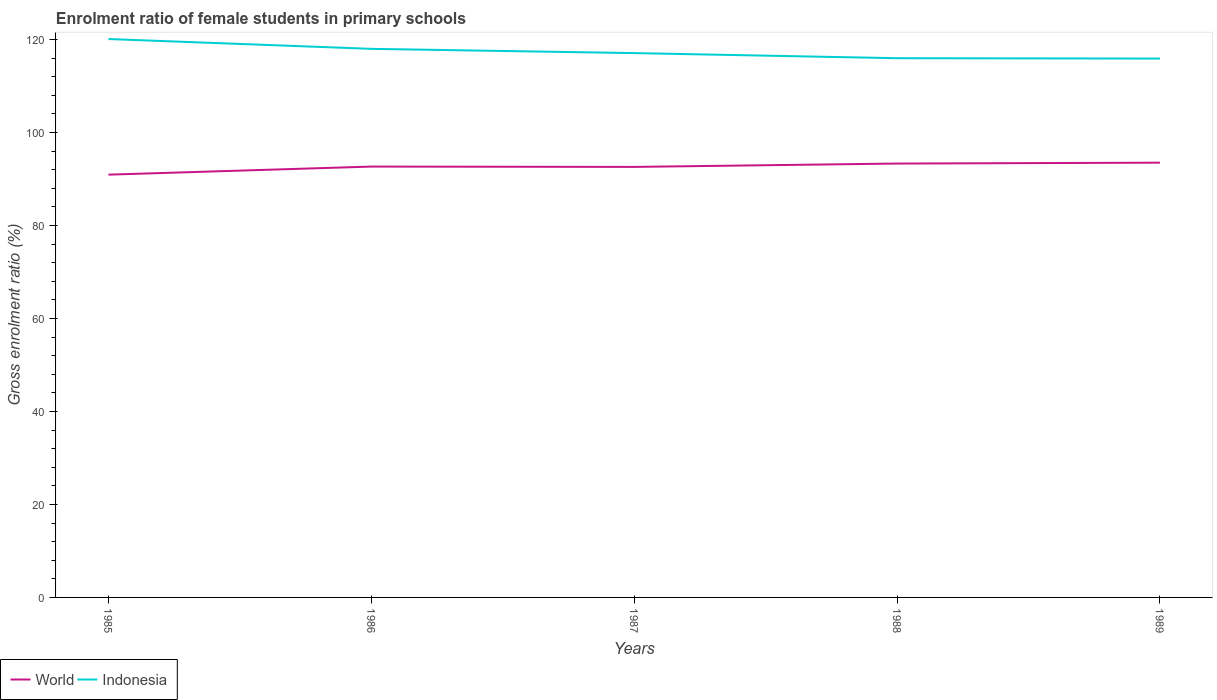Is the number of lines equal to the number of legend labels?
Your answer should be compact. Yes. Across all years, what is the maximum enrolment ratio of female students in primary schools in Indonesia?
Offer a very short reply. 115.91. What is the total enrolment ratio of female students in primary schools in Indonesia in the graph?
Offer a very short reply. 2.01. What is the difference between the highest and the second highest enrolment ratio of female students in primary schools in Indonesia?
Your answer should be very brief. 4.2. What is the difference between the highest and the lowest enrolment ratio of female students in primary schools in World?
Make the answer very short. 3. Is the enrolment ratio of female students in primary schools in World strictly greater than the enrolment ratio of female students in primary schools in Indonesia over the years?
Ensure brevity in your answer.  Yes. How many years are there in the graph?
Your answer should be very brief. 5. Does the graph contain any zero values?
Offer a very short reply. No. Does the graph contain grids?
Your response must be concise. No. Where does the legend appear in the graph?
Provide a short and direct response. Bottom left. How many legend labels are there?
Give a very brief answer. 2. What is the title of the graph?
Your answer should be compact. Enrolment ratio of female students in primary schools. Does "Pacific island small states" appear as one of the legend labels in the graph?
Provide a succinct answer. No. What is the label or title of the X-axis?
Give a very brief answer. Years. What is the label or title of the Y-axis?
Your answer should be very brief. Gross enrolment ratio (%). What is the Gross enrolment ratio (%) in World in 1985?
Provide a succinct answer. 90.94. What is the Gross enrolment ratio (%) of Indonesia in 1985?
Provide a short and direct response. 120.11. What is the Gross enrolment ratio (%) of World in 1986?
Offer a terse response. 92.68. What is the Gross enrolment ratio (%) of Indonesia in 1986?
Keep it short and to the point. 118. What is the Gross enrolment ratio (%) of World in 1987?
Ensure brevity in your answer.  92.61. What is the Gross enrolment ratio (%) of Indonesia in 1987?
Your answer should be very brief. 117.09. What is the Gross enrolment ratio (%) in World in 1988?
Keep it short and to the point. 93.33. What is the Gross enrolment ratio (%) of Indonesia in 1988?
Your answer should be compact. 115.99. What is the Gross enrolment ratio (%) in World in 1989?
Your answer should be compact. 93.52. What is the Gross enrolment ratio (%) of Indonesia in 1989?
Provide a succinct answer. 115.91. Across all years, what is the maximum Gross enrolment ratio (%) of World?
Provide a short and direct response. 93.52. Across all years, what is the maximum Gross enrolment ratio (%) of Indonesia?
Offer a very short reply. 120.11. Across all years, what is the minimum Gross enrolment ratio (%) of World?
Keep it short and to the point. 90.94. Across all years, what is the minimum Gross enrolment ratio (%) of Indonesia?
Offer a very short reply. 115.91. What is the total Gross enrolment ratio (%) in World in the graph?
Your answer should be very brief. 463.07. What is the total Gross enrolment ratio (%) of Indonesia in the graph?
Offer a very short reply. 587.11. What is the difference between the Gross enrolment ratio (%) of World in 1985 and that in 1986?
Make the answer very short. -1.74. What is the difference between the Gross enrolment ratio (%) of Indonesia in 1985 and that in 1986?
Your answer should be very brief. 2.11. What is the difference between the Gross enrolment ratio (%) in World in 1985 and that in 1987?
Offer a very short reply. -1.67. What is the difference between the Gross enrolment ratio (%) of Indonesia in 1985 and that in 1987?
Provide a short and direct response. 3.03. What is the difference between the Gross enrolment ratio (%) of World in 1985 and that in 1988?
Provide a succinct answer. -2.39. What is the difference between the Gross enrolment ratio (%) in Indonesia in 1985 and that in 1988?
Give a very brief answer. 4.12. What is the difference between the Gross enrolment ratio (%) of World in 1985 and that in 1989?
Offer a terse response. -2.58. What is the difference between the Gross enrolment ratio (%) in Indonesia in 1985 and that in 1989?
Provide a short and direct response. 4.2. What is the difference between the Gross enrolment ratio (%) of World in 1986 and that in 1987?
Offer a terse response. 0.07. What is the difference between the Gross enrolment ratio (%) of Indonesia in 1986 and that in 1987?
Offer a very short reply. 0.92. What is the difference between the Gross enrolment ratio (%) in World in 1986 and that in 1988?
Keep it short and to the point. -0.65. What is the difference between the Gross enrolment ratio (%) in Indonesia in 1986 and that in 1988?
Offer a terse response. 2.01. What is the difference between the Gross enrolment ratio (%) in World in 1986 and that in 1989?
Offer a very short reply. -0.84. What is the difference between the Gross enrolment ratio (%) in Indonesia in 1986 and that in 1989?
Give a very brief answer. 2.09. What is the difference between the Gross enrolment ratio (%) in World in 1987 and that in 1988?
Give a very brief answer. -0.72. What is the difference between the Gross enrolment ratio (%) in Indonesia in 1987 and that in 1988?
Provide a succinct answer. 1.1. What is the difference between the Gross enrolment ratio (%) in World in 1987 and that in 1989?
Offer a very short reply. -0.91. What is the difference between the Gross enrolment ratio (%) of Indonesia in 1987 and that in 1989?
Ensure brevity in your answer.  1.18. What is the difference between the Gross enrolment ratio (%) in World in 1988 and that in 1989?
Offer a very short reply. -0.19. What is the difference between the Gross enrolment ratio (%) of Indonesia in 1988 and that in 1989?
Ensure brevity in your answer.  0.08. What is the difference between the Gross enrolment ratio (%) in World in 1985 and the Gross enrolment ratio (%) in Indonesia in 1986?
Provide a succinct answer. -27.06. What is the difference between the Gross enrolment ratio (%) in World in 1985 and the Gross enrolment ratio (%) in Indonesia in 1987?
Give a very brief answer. -26.15. What is the difference between the Gross enrolment ratio (%) in World in 1985 and the Gross enrolment ratio (%) in Indonesia in 1988?
Ensure brevity in your answer.  -25.05. What is the difference between the Gross enrolment ratio (%) in World in 1985 and the Gross enrolment ratio (%) in Indonesia in 1989?
Offer a very short reply. -24.97. What is the difference between the Gross enrolment ratio (%) in World in 1986 and the Gross enrolment ratio (%) in Indonesia in 1987?
Offer a terse response. -24.41. What is the difference between the Gross enrolment ratio (%) of World in 1986 and the Gross enrolment ratio (%) of Indonesia in 1988?
Ensure brevity in your answer.  -23.31. What is the difference between the Gross enrolment ratio (%) of World in 1986 and the Gross enrolment ratio (%) of Indonesia in 1989?
Give a very brief answer. -23.23. What is the difference between the Gross enrolment ratio (%) of World in 1987 and the Gross enrolment ratio (%) of Indonesia in 1988?
Make the answer very short. -23.38. What is the difference between the Gross enrolment ratio (%) of World in 1987 and the Gross enrolment ratio (%) of Indonesia in 1989?
Your answer should be compact. -23.3. What is the difference between the Gross enrolment ratio (%) in World in 1988 and the Gross enrolment ratio (%) in Indonesia in 1989?
Your response must be concise. -22.58. What is the average Gross enrolment ratio (%) in World per year?
Make the answer very short. 92.61. What is the average Gross enrolment ratio (%) in Indonesia per year?
Your answer should be compact. 117.42. In the year 1985, what is the difference between the Gross enrolment ratio (%) of World and Gross enrolment ratio (%) of Indonesia?
Provide a succinct answer. -29.17. In the year 1986, what is the difference between the Gross enrolment ratio (%) in World and Gross enrolment ratio (%) in Indonesia?
Give a very brief answer. -25.33. In the year 1987, what is the difference between the Gross enrolment ratio (%) of World and Gross enrolment ratio (%) of Indonesia?
Your answer should be compact. -24.48. In the year 1988, what is the difference between the Gross enrolment ratio (%) of World and Gross enrolment ratio (%) of Indonesia?
Your response must be concise. -22.66. In the year 1989, what is the difference between the Gross enrolment ratio (%) of World and Gross enrolment ratio (%) of Indonesia?
Your answer should be compact. -22.39. What is the ratio of the Gross enrolment ratio (%) in World in 1985 to that in 1986?
Offer a terse response. 0.98. What is the ratio of the Gross enrolment ratio (%) of Indonesia in 1985 to that in 1986?
Keep it short and to the point. 1.02. What is the ratio of the Gross enrolment ratio (%) in Indonesia in 1985 to that in 1987?
Your answer should be very brief. 1.03. What is the ratio of the Gross enrolment ratio (%) of World in 1985 to that in 1988?
Offer a very short reply. 0.97. What is the ratio of the Gross enrolment ratio (%) of Indonesia in 1985 to that in 1988?
Offer a terse response. 1.04. What is the ratio of the Gross enrolment ratio (%) in World in 1985 to that in 1989?
Provide a succinct answer. 0.97. What is the ratio of the Gross enrolment ratio (%) of Indonesia in 1985 to that in 1989?
Provide a short and direct response. 1.04. What is the ratio of the Gross enrolment ratio (%) of Indonesia in 1986 to that in 1987?
Offer a terse response. 1.01. What is the ratio of the Gross enrolment ratio (%) of Indonesia in 1986 to that in 1988?
Your answer should be very brief. 1.02. What is the ratio of the Gross enrolment ratio (%) of Indonesia in 1986 to that in 1989?
Provide a succinct answer. 1.02. What is the ratio of the Gross enrolment ratio (%) of Indonesia in 1987 to that in 1988?
Ensure brevity in your answer.  1.01. What is the ratio of the Gross enrolment ratio (%) of World in 1987 to that in 1989?
Provide a short and direct response. 0.99. What is the ratio of the Gross enrolment ratio (%) in Indonesia in 1987 to that in 1989?
Make the answer very short. 1.01. What is the ratio of the Gross enrolment ratio (%) in World in 1988 to that in 1989?
Give a very brief answer. 1. What is the difference between the highest and the second highest Gross enrolment ratio (%) of World?
Ensure brevity in your answer.  0.19. What is the difference between the highest and the second highest Gross enrolment ratio (%) in Indonesia?
Provide a short and direct response. 2.11. What is the difference between the highest and the lowest Gross enrolment ratio (%) of World?
Your response must be concise. 2.58. What is the difference between the highest and the lowest Gross enrolment ratio (%) in Indonesia?
Your answer should be compact. 4.2. 